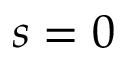<formula> <loc_0><loc_0><loc_500><loc_500>s = 0</formula> 